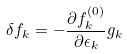<formula> <loc_0><loc_0><loc_500><loc_500>\delta f _ { k } = - \frac { \partial f _ { k } ^ { ( 0 ) } } { \partial \epsilon _ { k } } g _ { k }</formula> 